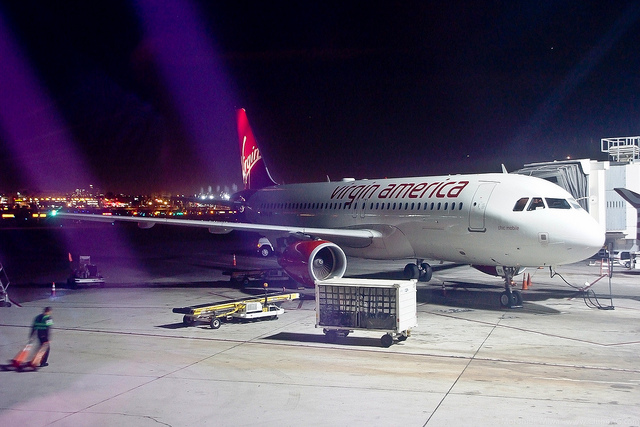<image>Is this an express flight? I don't know if this is an express flight. The answer could be both yes and no. Is this an express flight? I don't know if this is an express flight. It can be either yes or no. 